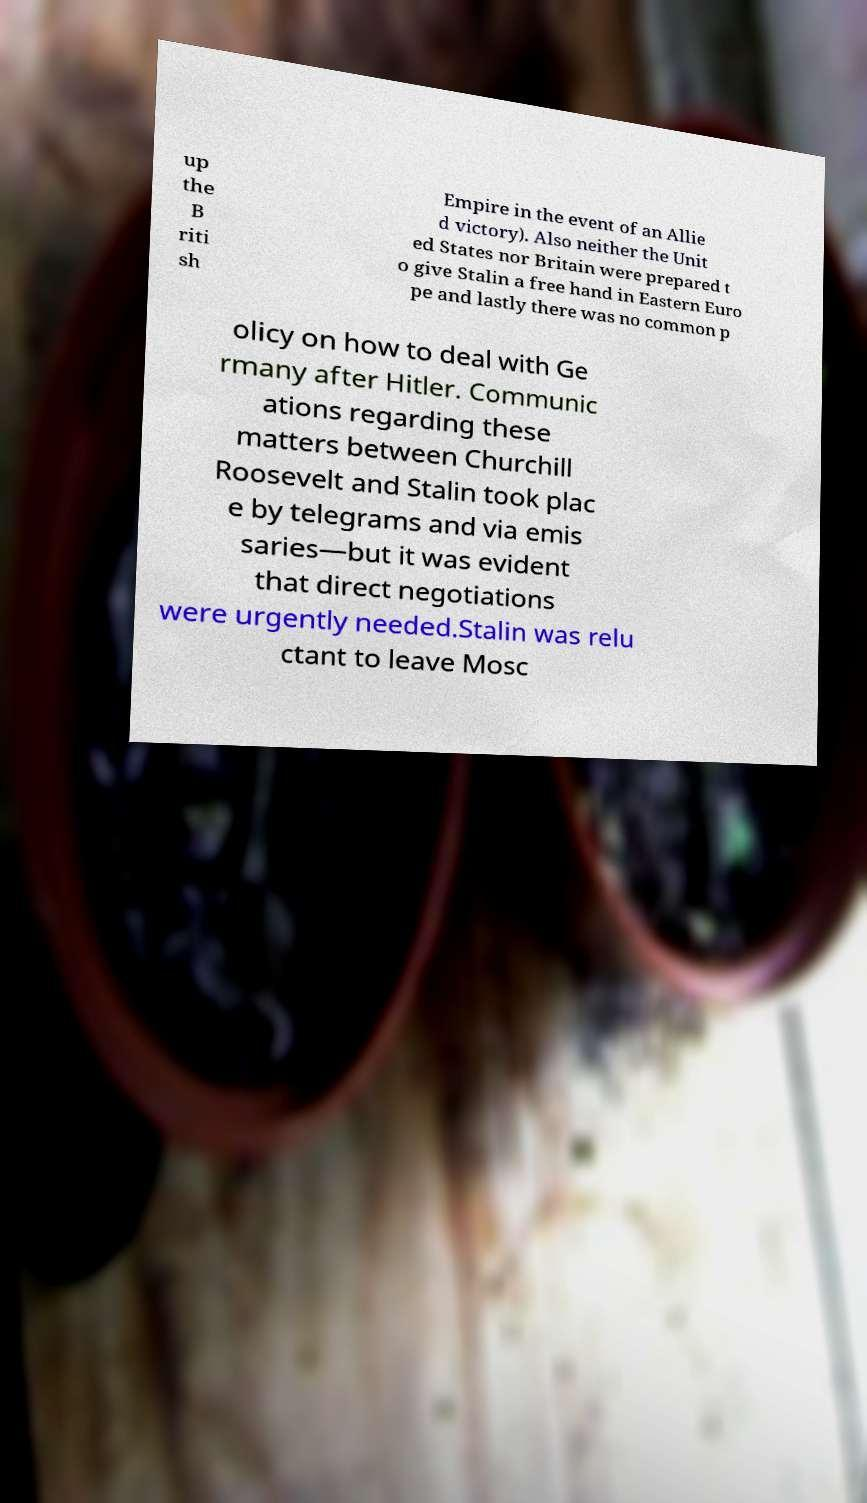I need the written content from this picture converted into text. Can you do that? up the B riti sh Empire in the event of an Allie d victory). Also neither the Unit ed States nor Britain were prepared t o give Stalin a free hand in Eastern Euro pe and lastly there was no common p olicy on how to deal with Ge rmany after Hitler. Communic ations regarding these matters between Churchill Roosevelt and Stalin took plac e by telegrams and via emis saries—but it was evident that direct negotiations were urgently needed.Stalin was relu ctant to leave Mosc 